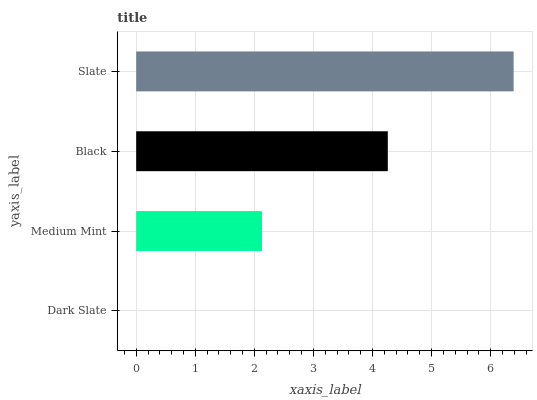Is Dark Slate the minimum?
Answer yes or no. Yes. Is Slate the maximum?
Answer yes or no. Yes. Is Medium Mint the minimum?
Answer yes or no. No. Is Medium Mint the maximum?
Answer yes or no. No. Is Medium Mint greater than Dark Slate?
Answer yes or no. Yes. Is Dark Slate less than Medium Mint?
Answer yes or no. Yes. Is Dark Slate greater than Medium Mint?
Answer yes or no. No. Is Medium Mint less than Dark Slate?
Answer yes or no. No. Is Black the high median?
Answer yes or no. Yes. Is Medium Mint the low median?
Answer yes or no. Yes. Is Dark Slate the high median?
Answer yes or no. No. Is Black the low median?
Answer yes or no. No. 